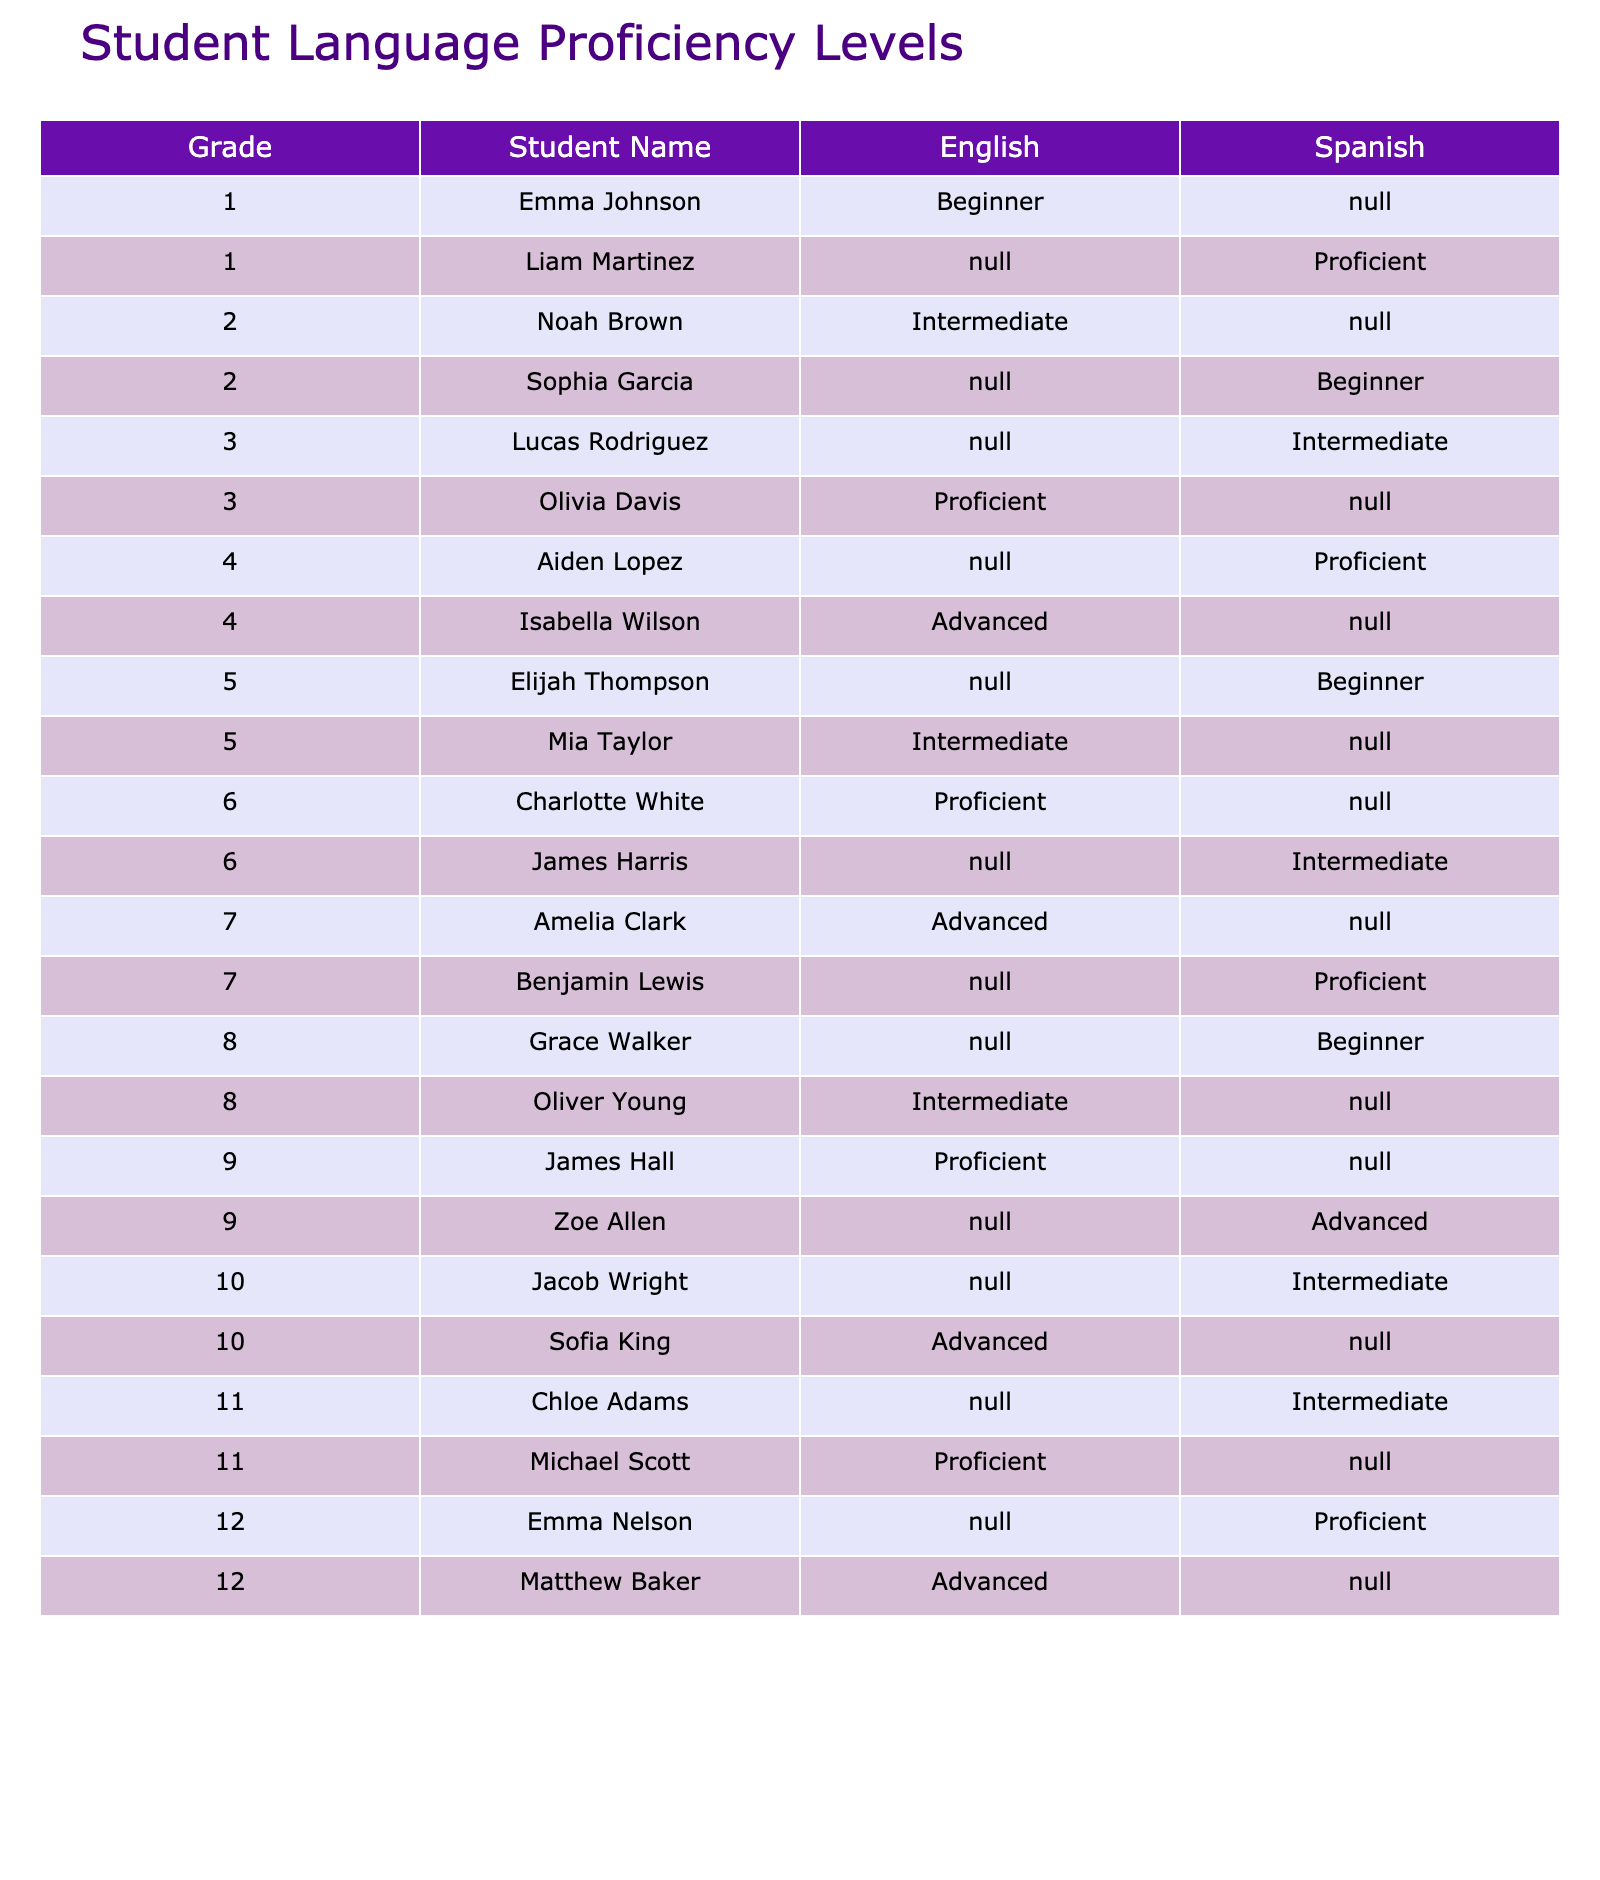What is Liam Martinez's language proficiency level in Spanish? The table lists Liam Martinez under Grade 1 for the subject of Spanish, indicating his proficiency level is Proficient.
Answer: Proficient Which student has the highest language proficiency in English? The table shows that Isabella Wilson, under Grade 4, is listed as Advanced in English, which is the highest proficiency level.
Answer: Isabella Wilson How many students are in the Beginner level for Spanish? Referring to the table, Sophia Garcia, Elijah Thompson, and Grace Walker are identified as Beginners in Spanish, totaling three students.
Answer: 3 Is there a student who is Advanced in both English and Spanish? Upon examining the table, it is noted that no student is listed as Advanced in both subjects; for Spanish, the advanced level is only achieved by Zoe Allen in Grade 9.
Answer: No What is the difference in the number of Proficient students between English and Spanish? Counting the Proficient students in English (5: Liam, Olivia, Charlotte, Amelia, Michael) and in Spanish (5: Aiden, Lucas, Benjamin, Emma, Zoe), there is no difference.
Answer: 0 Which student in Grade 12 has the highest proficiency in English? The table indicates that Matthew Baker is Advanced in English within Grade 12, making him the highest in this category.
Answer: Matthew Baker Are there more Intermediate students in Spanish or English? In Spanish, counting the Intermediate students (3: Lucas, James, Chloe) and in English (4: Noah, Mia, Jacob, Chloe) shows English has more Intermediate students.
Answer: English Which grade has the most students classified as Proficient in any language? Analyzing the table, Grades 7 and 9 both have three students classified as Proficient, which is the highest among all grades.
Answer: Grade 7 and Grade 9 What is the average language proficiency level for Grade 5 students? In Grade 5, Mia Taylor is Intermediate in English and Elijah Thompson is Beginner in Spanish. The average is calculated by considering the proficiency levels numerically: Intermediate (3) + Beginner (1) = 4, divided by 2 results in an average of 2.
Answer: 2 In which subject does the highest number of students hold an Advanced proficiency? By reviewing the table, there are five Advanced students in English (Isabella, James, Sofia, Michael, and Matthew), compared to two in Spanish (Zoe and possibly others). Thus, English has more students at this level.
Answer: English 